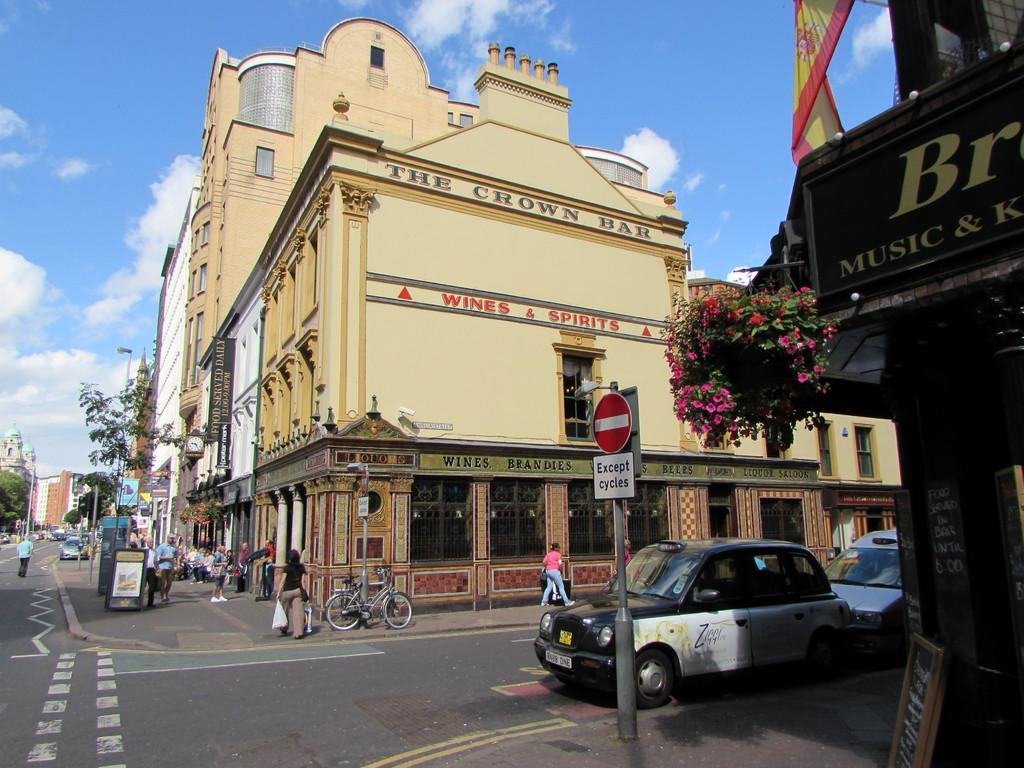<image>
Relay a brief, clear account of the picture shown. A sign reads no entry except for cycles. 